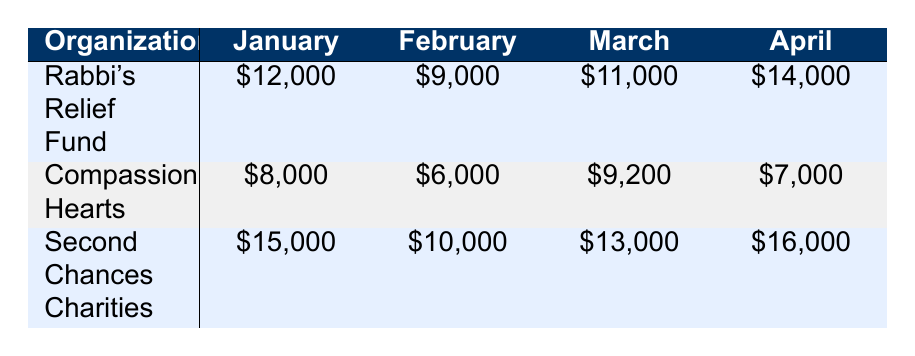What was the total amount donated to Second Chances Charities in February? To find the total for Second Chances Charities in February, we look directly at the table and find the amount listed under that organization for February, which is $10,000.
Answer: 10000 Which organization received the highest donation in January? In January, we compare the amounts received by each organization: Rabbi's Relief Fund received $12,000, Compassionate Hearts received $8,000, and Second Chances Charities received $15,000. Since $15,000 is the highest amount, Second Chances Charities received the most.
Answer: Second Chances Charities What was the difference in donations received by Rabbi's Relief Fund between January and April? We first find the amounts for Rabbi's Relief Fund in both January and April from the table: January is $12,000 and April is $14,000. The difference is calculated by subtracting the January amount from the April amount: $14,000 - $12,000 = $2,000.
Answer: 2000 Is the total amount received by Compassionate Hearts for all months greater than $30,000? To answer this, we add the amounts received in each month: January: $8,000, February: $6,000, March: $9,200, and April: $7,000. The total is $8,000 + $6,000 + $9,200 + $7,000 = $30,200, which is greater than $30,000.
Answer: Yes What is the average monthly donation for Second Chances Charities over the four months listed? To calculate the average, we first add the monthly donations: $15,000 (January) + $10,000 (February) + $13,000 (March) + $16,000 (April) = $54,000. Then, we divide by the number of months (4): $54,000 / 4 = $13,500, which gives us the average donation.
Answer: 13500 